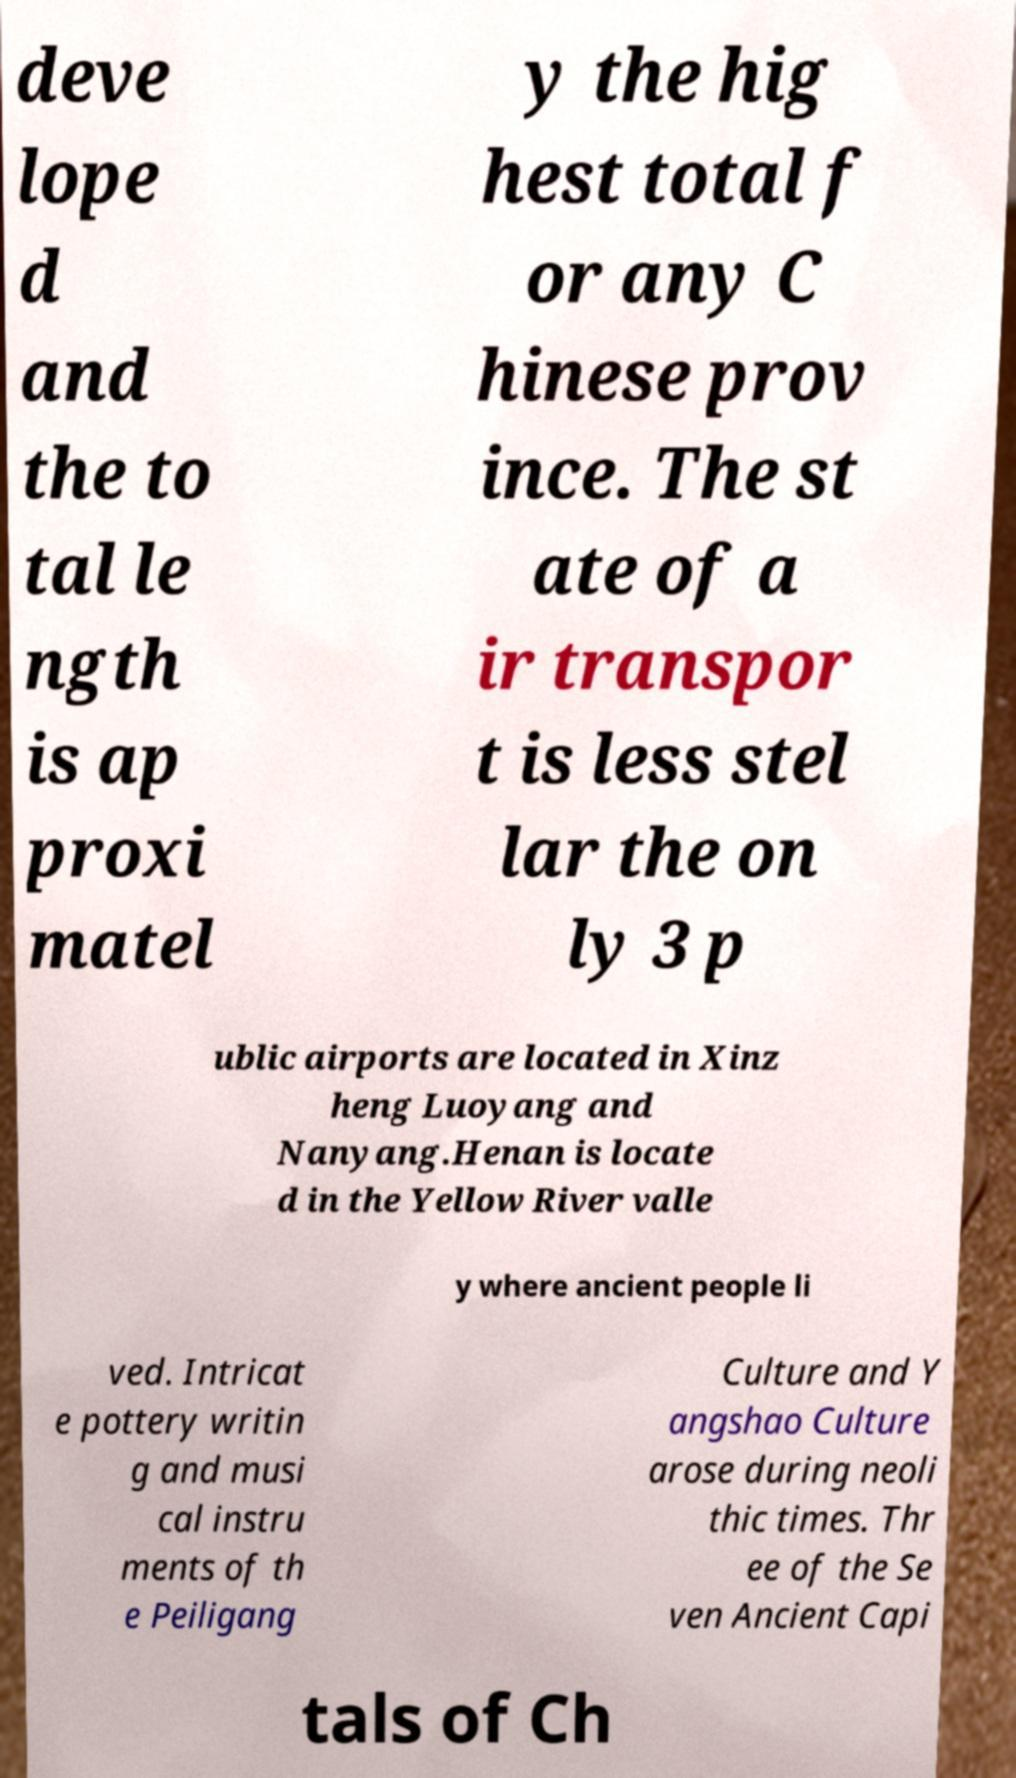I need the written content from this picture converted into text. Can you do that? deve lope d and the to tal le ngth is ap proxi matel y the hig hest total f or any C hinese prov ince. The st ate of a ir transpor t is less stel lar the on ly 3 p ublic airports are located in Xinz heng Luoyang and Nanyang.Henan is locate d in the Yellow River valle y where ancient people li ved. Intricat e pottery writin g and musi cal instru ments of th e Peiligang Culture and Y angshao Culture arose during neoli thic times. Thr ee of the Se ven Ancient Capi tals of Ch 